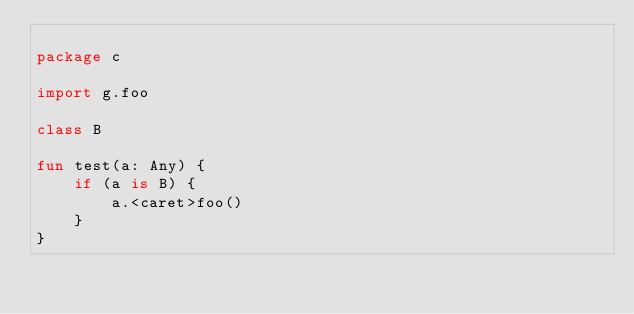<code> <loc_0><loc_0><loc_500><loc_500><_Kotlin_>
package c

import g.foo

class B

fun test(a: Any) {
    if (a is B) {
        a.<caret>foo()
    }
}</code> 